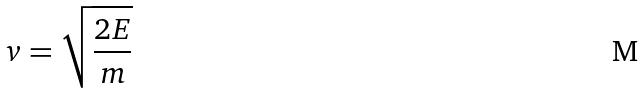<formula> <loc_0><loc_0><loc_500><loc_500>v = \sqrt { \frac { 2 E } { m } }</formula> 